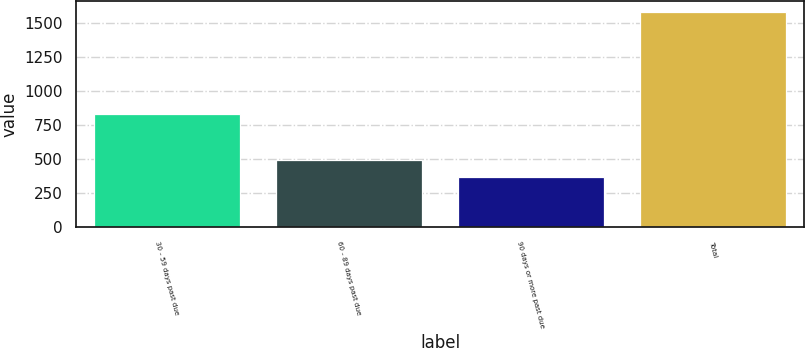<chart> <loc_0><loc_0><loc_500><loc_500><bar_chart><fcel>30 - 59 days past due<fcel>60 - 89 days past due<fcel>90 days or more past due<fcel>Total<nl><fcel>833<fcel>491.5<fcel>370<fcel>1585<nl></chart> 